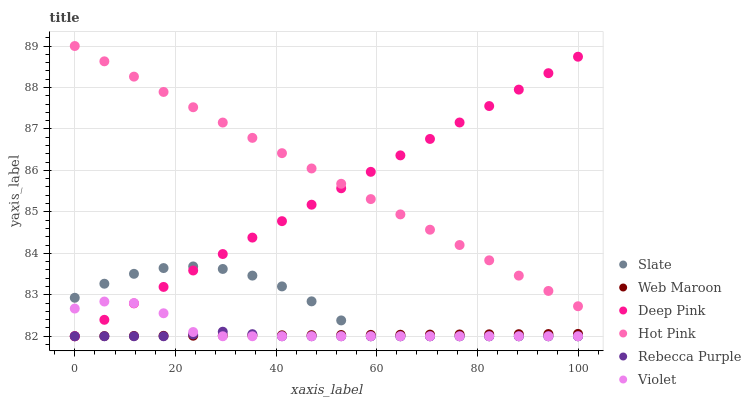Does Rebecca Purple have the minimum area under the curve?
Answer yes or no. Yes. Does Hot Pink have the maximum area under the curve?
Answer yes or no. Yes. Does Slate have the minimum area under the curve?
Answer yes or no. No. Does Slate have the maximum area under the curve?
Answer yes or no. No. Is Hot Pink the smoothest?
Answer yes or no. Yes. Is Slate the roughest?
Answer yes or no. Yes. Is Slate the smoothest?
Answer yes or no. No. Is Hot Pink the roughest?
Answer yes or no. No. Does Deep Pink have the lowest value?
Answer yes or no. Yes. Does Hot Pink have the lowest value?
Answer yes or no. No. Does Hot Pink have the highest value?
Answer yes or no. Yes. Does Slate have the highest value?
Answer yes or no. No. Is Rebecca Purple less than Hot Pink?
Answer yes or no. Yes. Is Hot Pink greater than Web Maroon?
Answer yes or no. Yes. Does Deep Pink intersect Web Maroon?
Answer yes or no. Yes. Is Deep Pink less than Web Maroon?
Answer yes or no. No. Is Deep Pink greater than Web Maroon?
Answer yes or no. No. Does Rebecca Purple intersect Hot Pink?
Answer yes or no. No. 